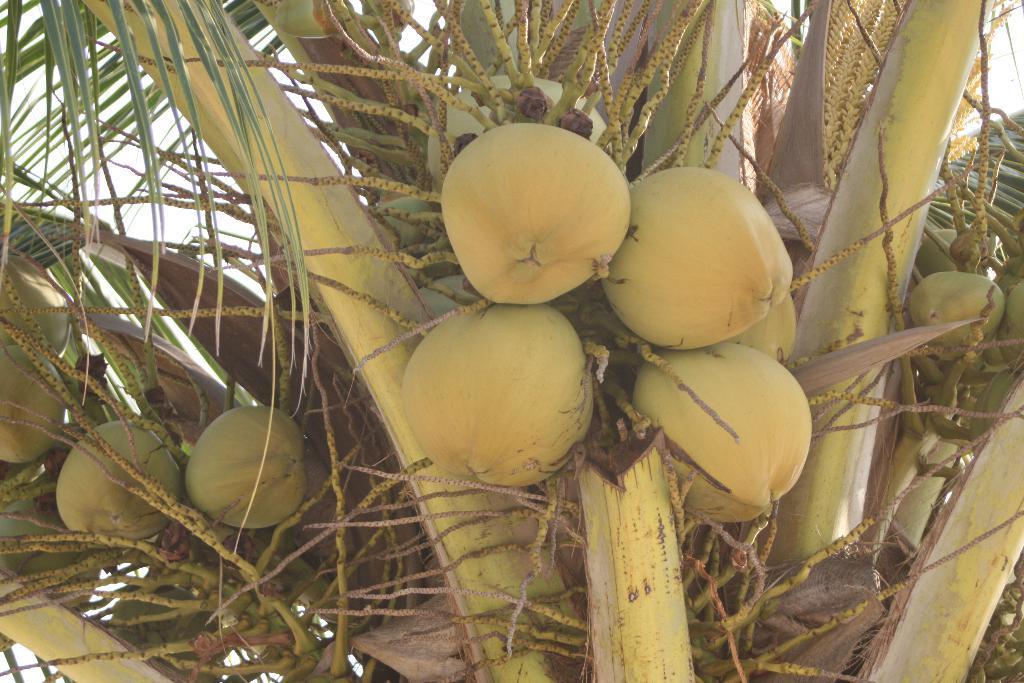What type of tree is present in the image? There is a tree with coconuts in the image. What can be seen in the background of the image? The sky is visible in the background of the image. How many teeth can be seen in the image? There are no teeth present in the image; it features a tree with coconuts and a sky background. 